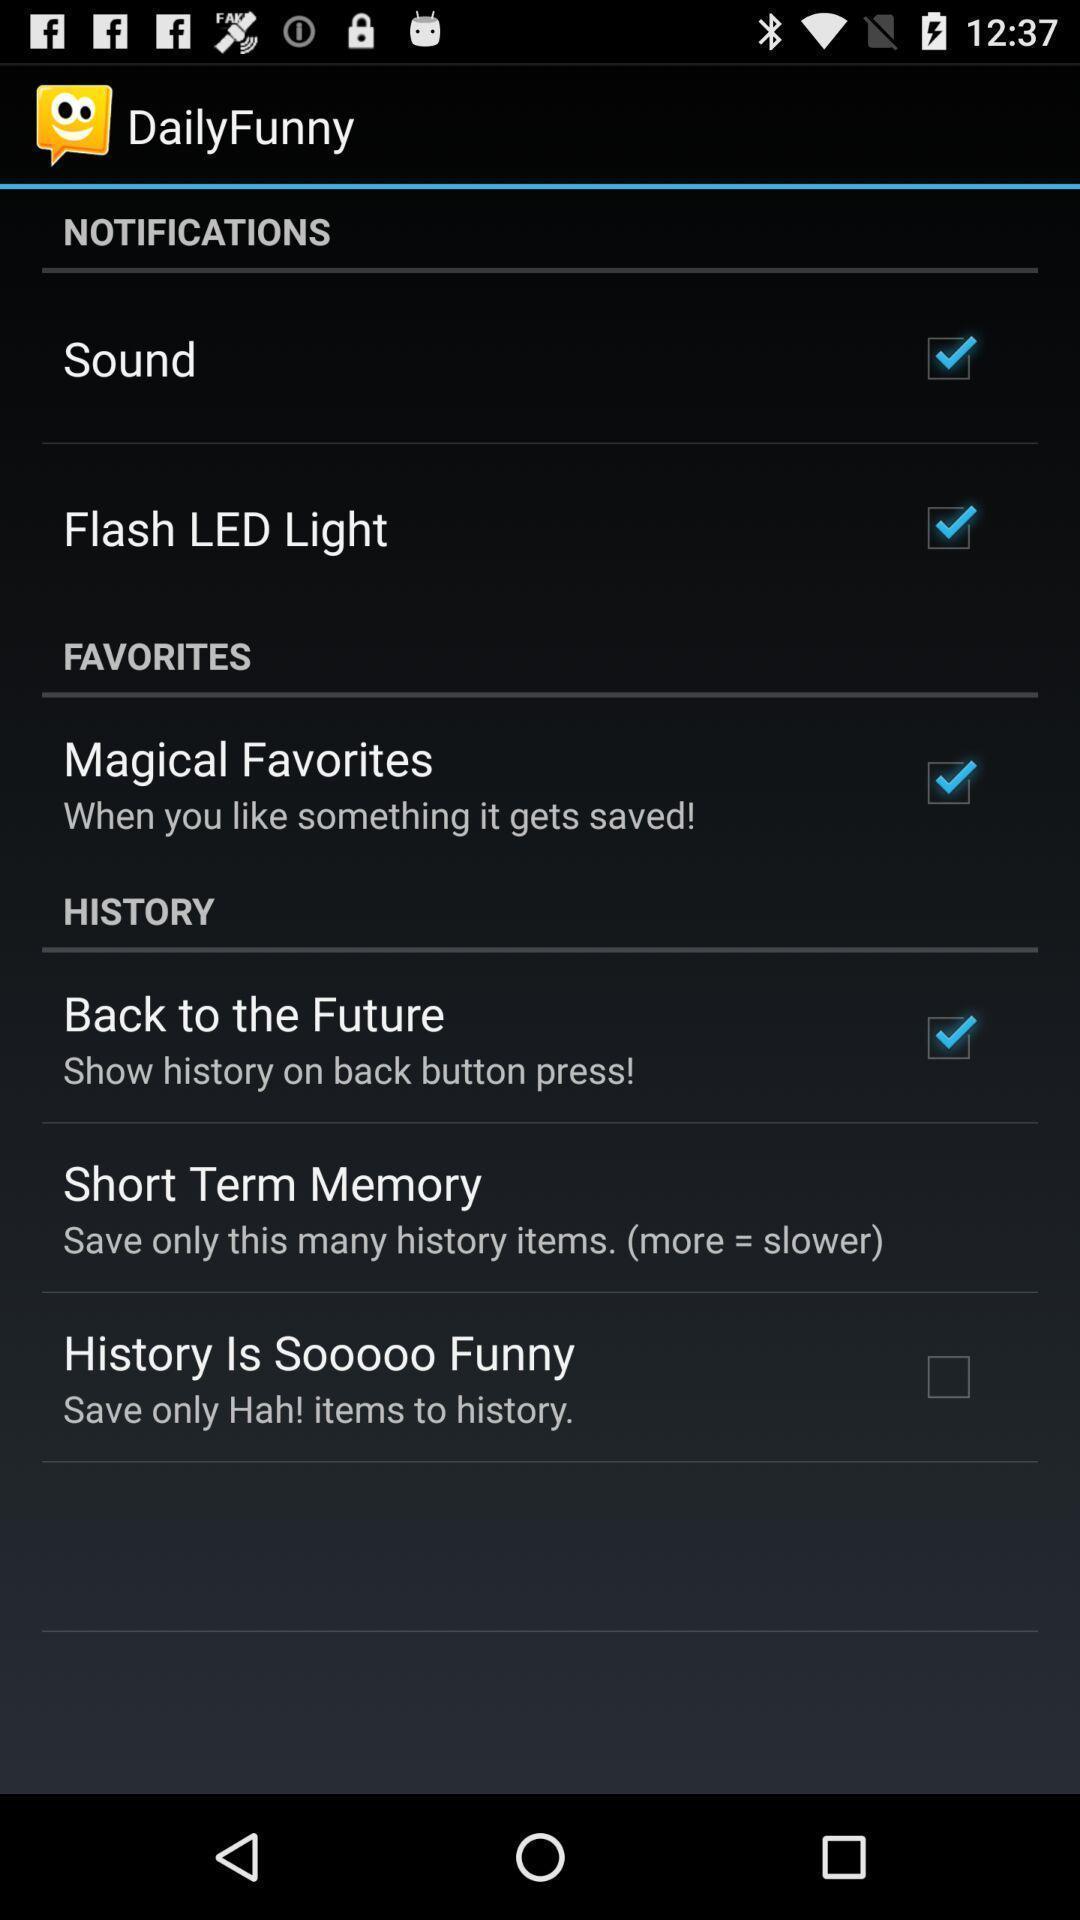Give me a summary of this screen capture. Screen displaying multiple setting options. 